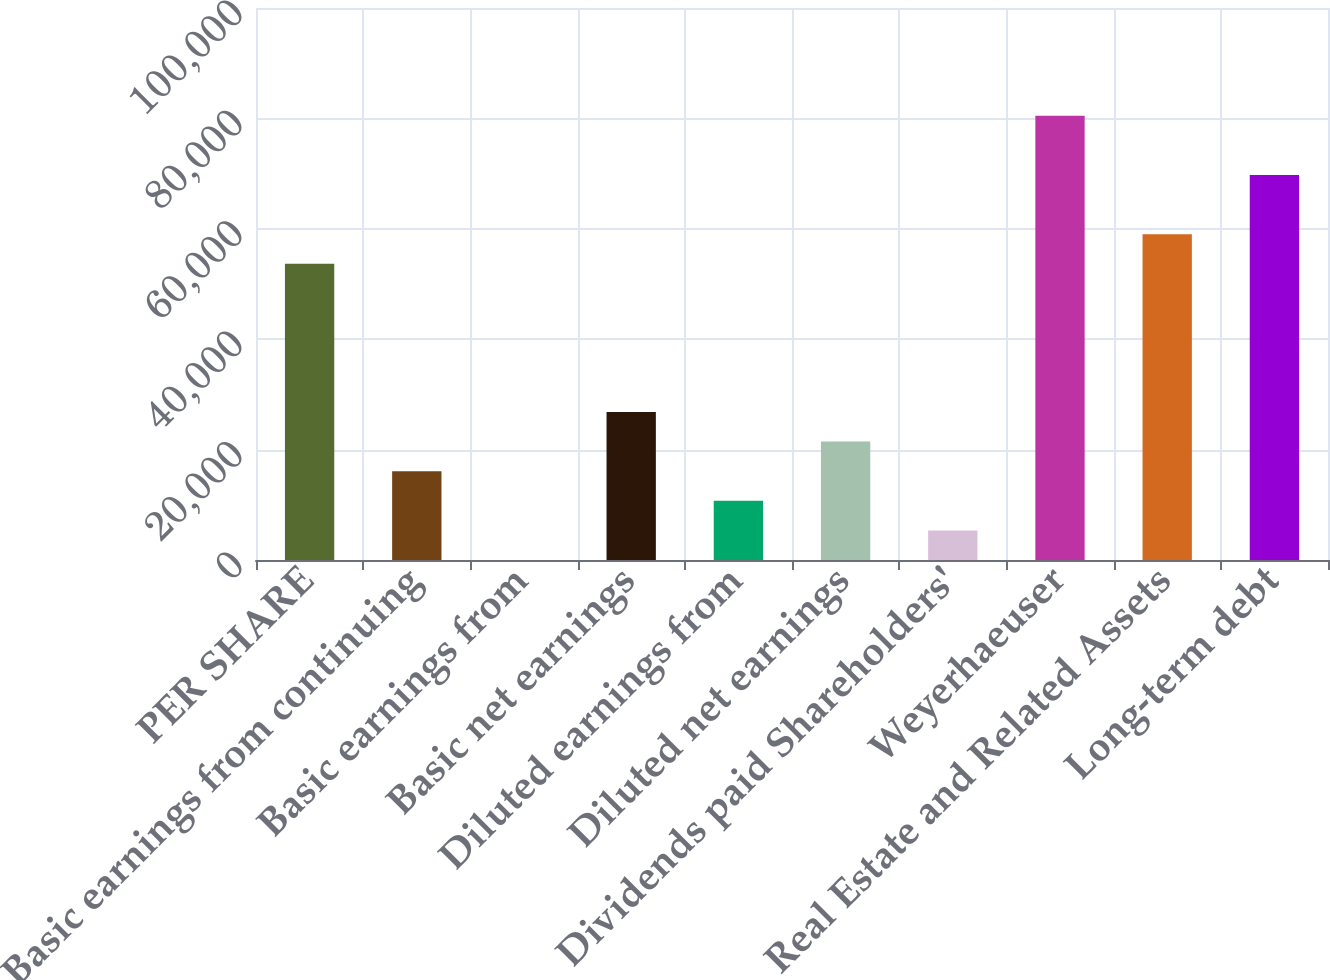Convert chart to OTSL. <chart><loc_0><loc_0><loc_500><loc_500><bar_chart><fcel>PER SHARE<fcel>Basic earnings from continuing<fcel>Basic earnings from<fcel>Basic net earnings<fcel>Diluted earnings from<fcel>Diluted net earnings<fcel>Dividends paid Shareholders'<fcel>Weyerhaeuser<fcel>Real Estate and Related Assets<fcel>Long-term debt<nl><fcel>53646<fcel>16094<fcel>0.29<fcel>26823.1<fcel>10729.4<fcel>21458.6<fcel>5364.86<fcel>80468.8<fcel>59010.6<fcel>69739.7<nl></chart> 